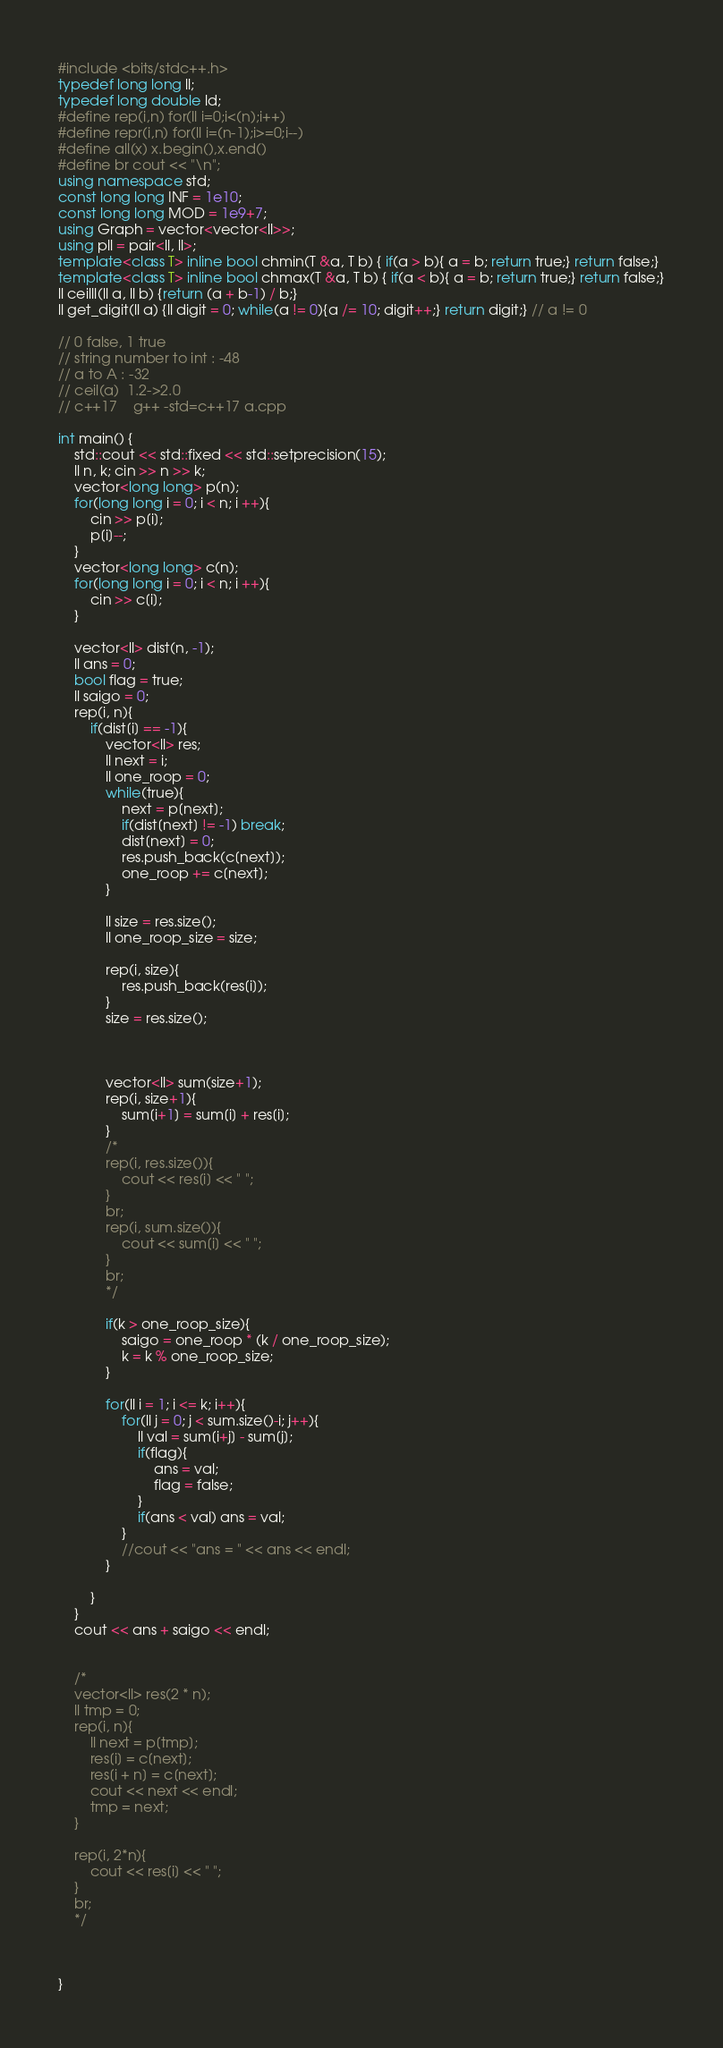<code> <loc_0><loc_0><loc_500><loc_500><_C++_>#include <bits/stdc++.h>
typedef long long ll;
typedef long double ld;
#define rep(i,n) for(ll i=0;i<(n);i++)
#define repr(i,n) for(ll i=(n-1);i>=0;i--)
#define all(x) x.begin(),x.end()
#define br cout << "\n";
using namespace std;
const long long INF = 1e10;
const long long MOD = 1e9+7;
using Graph = vector<vector<ll>>;
using pll = pair<ll, ll>;
template<class T> inline bool chmin(T &a, T b) { if(a > b){ a = b; return true;} return false;}
template<class T> inline bool chmax(T &a, T b) { if(a < b){ a = b; return true;} return false;}
ll ceilll(ll a, ll b) {return (a + b-1) / b;}
ll get_digit(ll a) {ll digit = 0; while(a != 0){a /= 10; digit++;} return digit;} // a != 0

// 0 false, 1 true 
// string number to int : -48
// a to A : -32
// ceil(a)  1.2->2.0
// c++17	g++ -std=c++17 a.cpp

int main() {
    std::cout << std::fixed << std::setprecision(15);
    ll n, k; cin >> n >> k;
    vector<long long> p(n);
    for(long long i = 0; i < n; i ++){
        cin >> p[i];
        p[i]--;
    }
    vector<long long> c(n);
    for(long long i = 0; i < n; i ++){
        cin >> c[i];
    }

    vector<ll> dist(n, -1);
    ll ans = 0;
    bool flag = true;
    ll saigo = 0;
    rep(i, n){
        if(dist[i] == -1){
            vector<ll> res;
            ll next = i;
            ll one_roop = 0;
            while(true){
                next = p[next];
                if(dist[next] != -1) break;
                dist[next] = 0;
                res.push_back(c[next]);
                one_roop += c[next];
            }
            
            ll size = res.size();
            ll one_roop_size = size;
            
            rep(i, size){
                res.push_back(res[i]);
            }
            size = res.size();

            

            vector<ll> sum(size+1);
            rep(i, size+1){
                sum[i+1] = sum[i] + res[i];
            }
            /*
            rep(i, res.size()){
                cout << res[i] << " ";
            }
            br;
            rep(i, sum.size()){
                cout << sum[i] << " ";
            }
            br;
            */

            if(k > one_roop_size){
                saigo = one_roop * (k / one_roop_size);
                k = k % one_roop_size;
            }

            for(ll i = 1; i <= k; i++){
                for(ll j = 0; j < sum.size()-i; j++){
                    ll val = sum[i+j] - sum[j];
                    if(flag){
                        ans = val;
                        flag = false;
                    } 
                    if(ans < val) ans = val;
                }
                //cout << "ans = " << ans << endl;
            }
            
        } 
    }
    cout << ans + saigo << endl;


    /*
    vector<ll> res(2 * n);
    ll tmp = 0;
    rep(i, n){
        ll next = p[tmp];
        res[i] = c[next];
        res[i + n] = c[next];
        cout << next << endl;
        tmp = next;
    }

    rep(i, 2*n){
        cout << res[i] << " ";
    }
    br;
    */



}</code> 